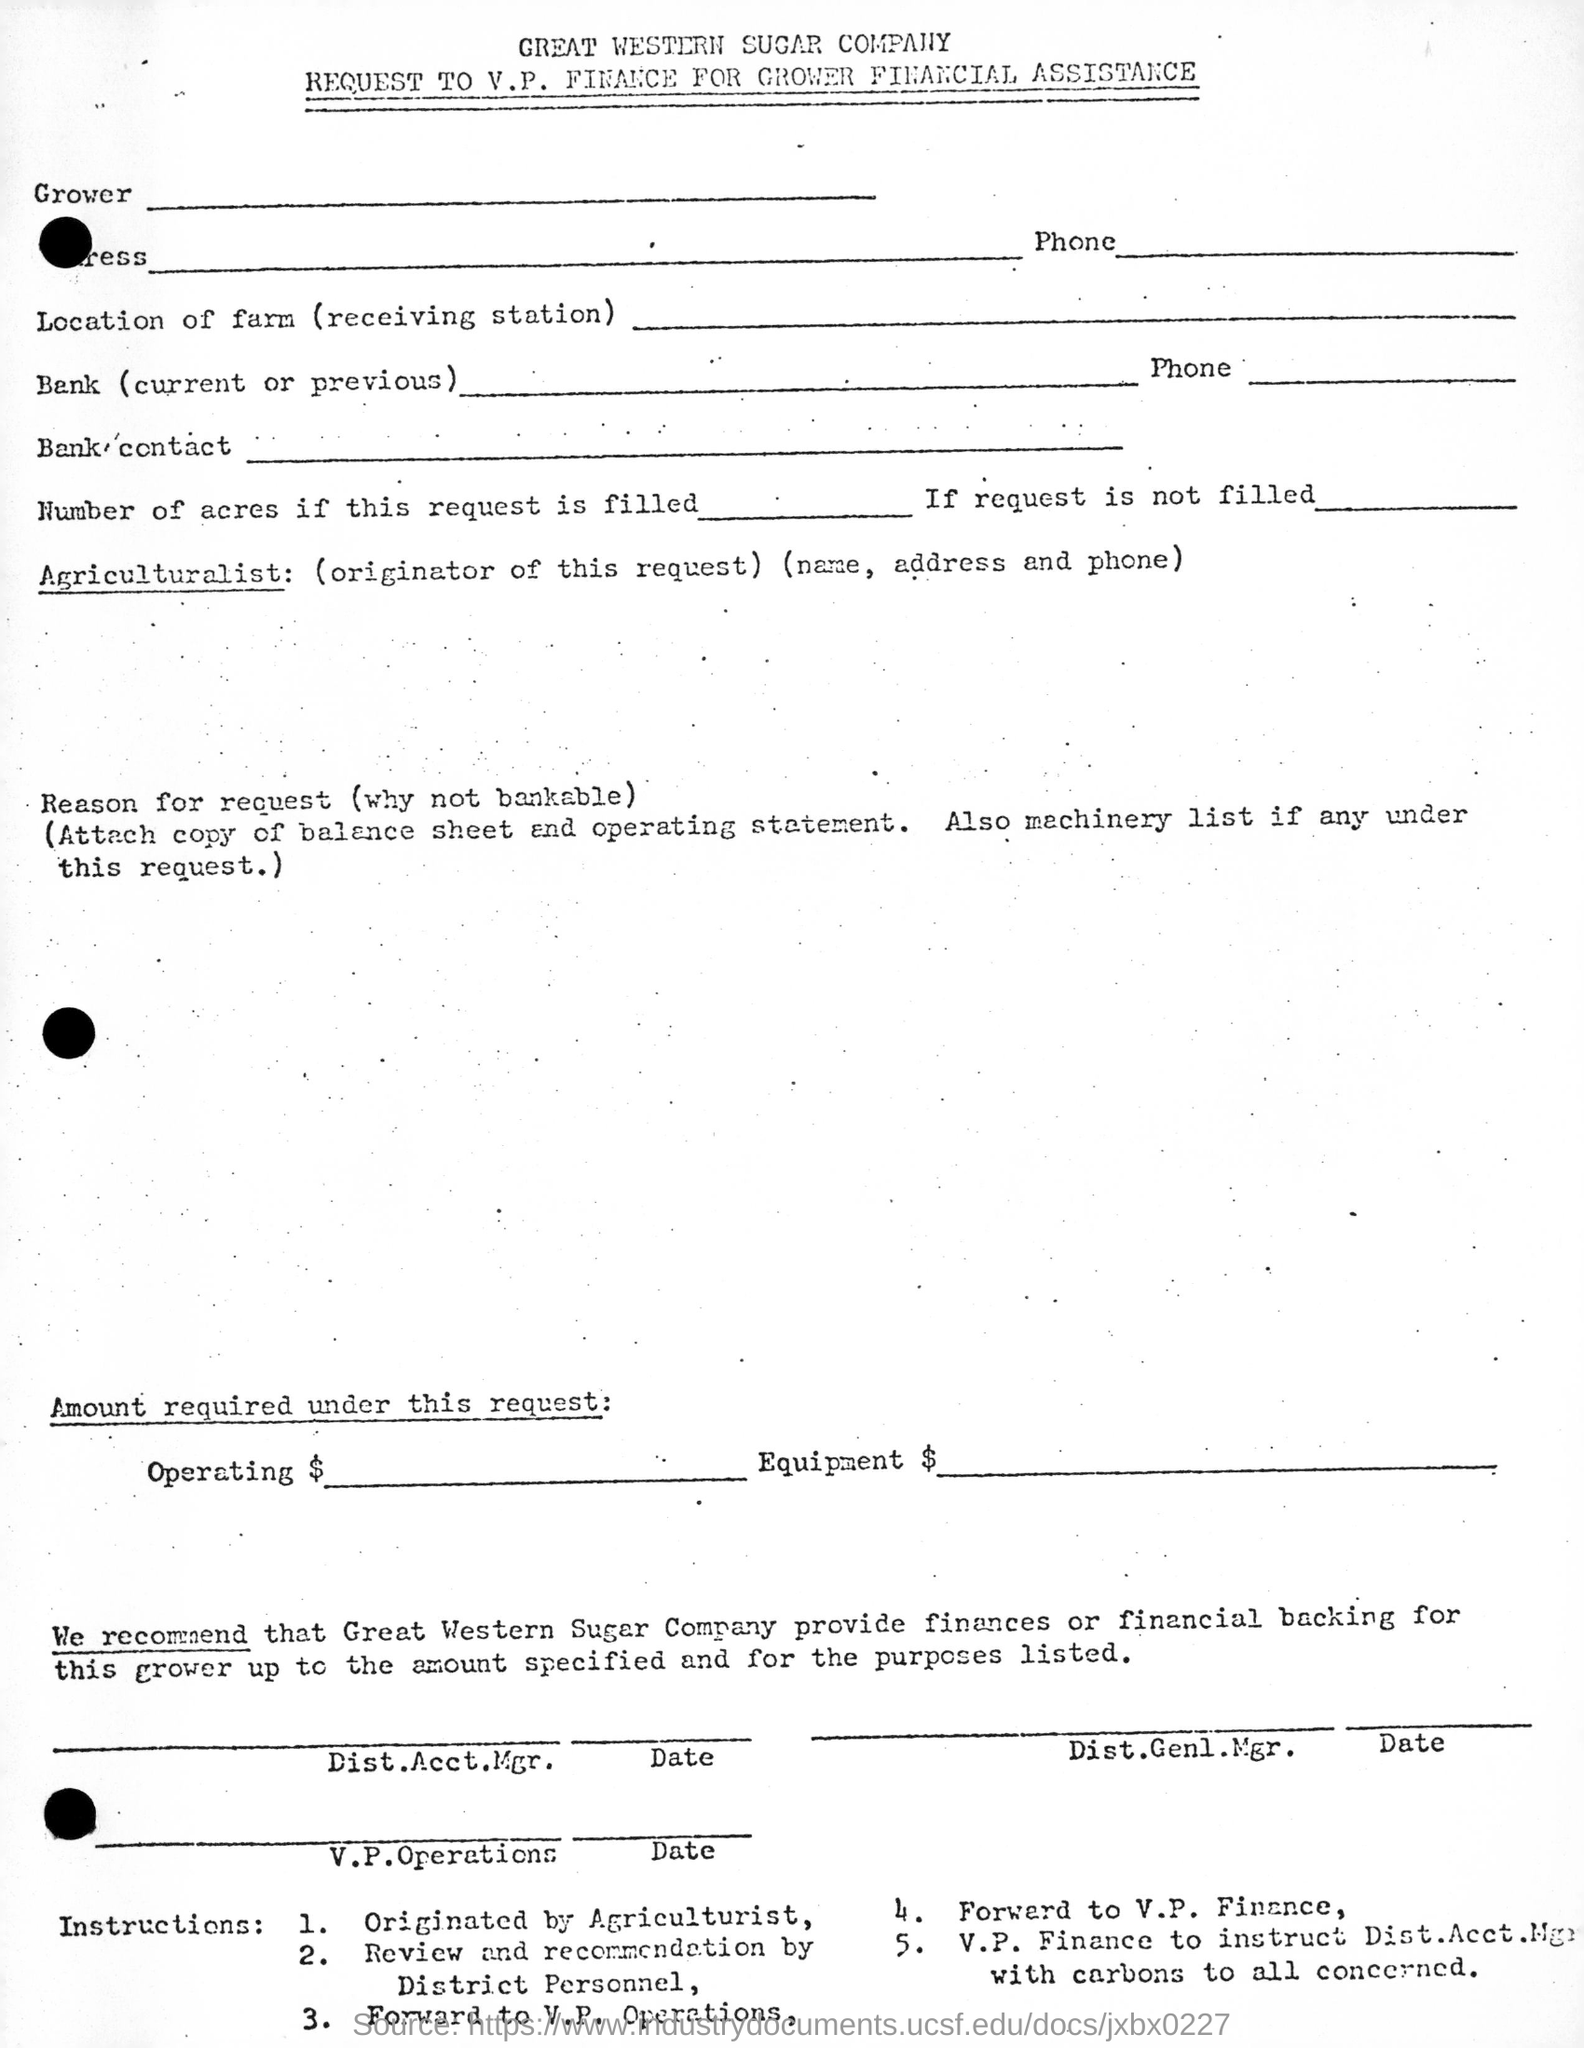Which company is mentioned in this document?
Offer a terse response. GREAT WESTERN SUGAR COMPANY. 